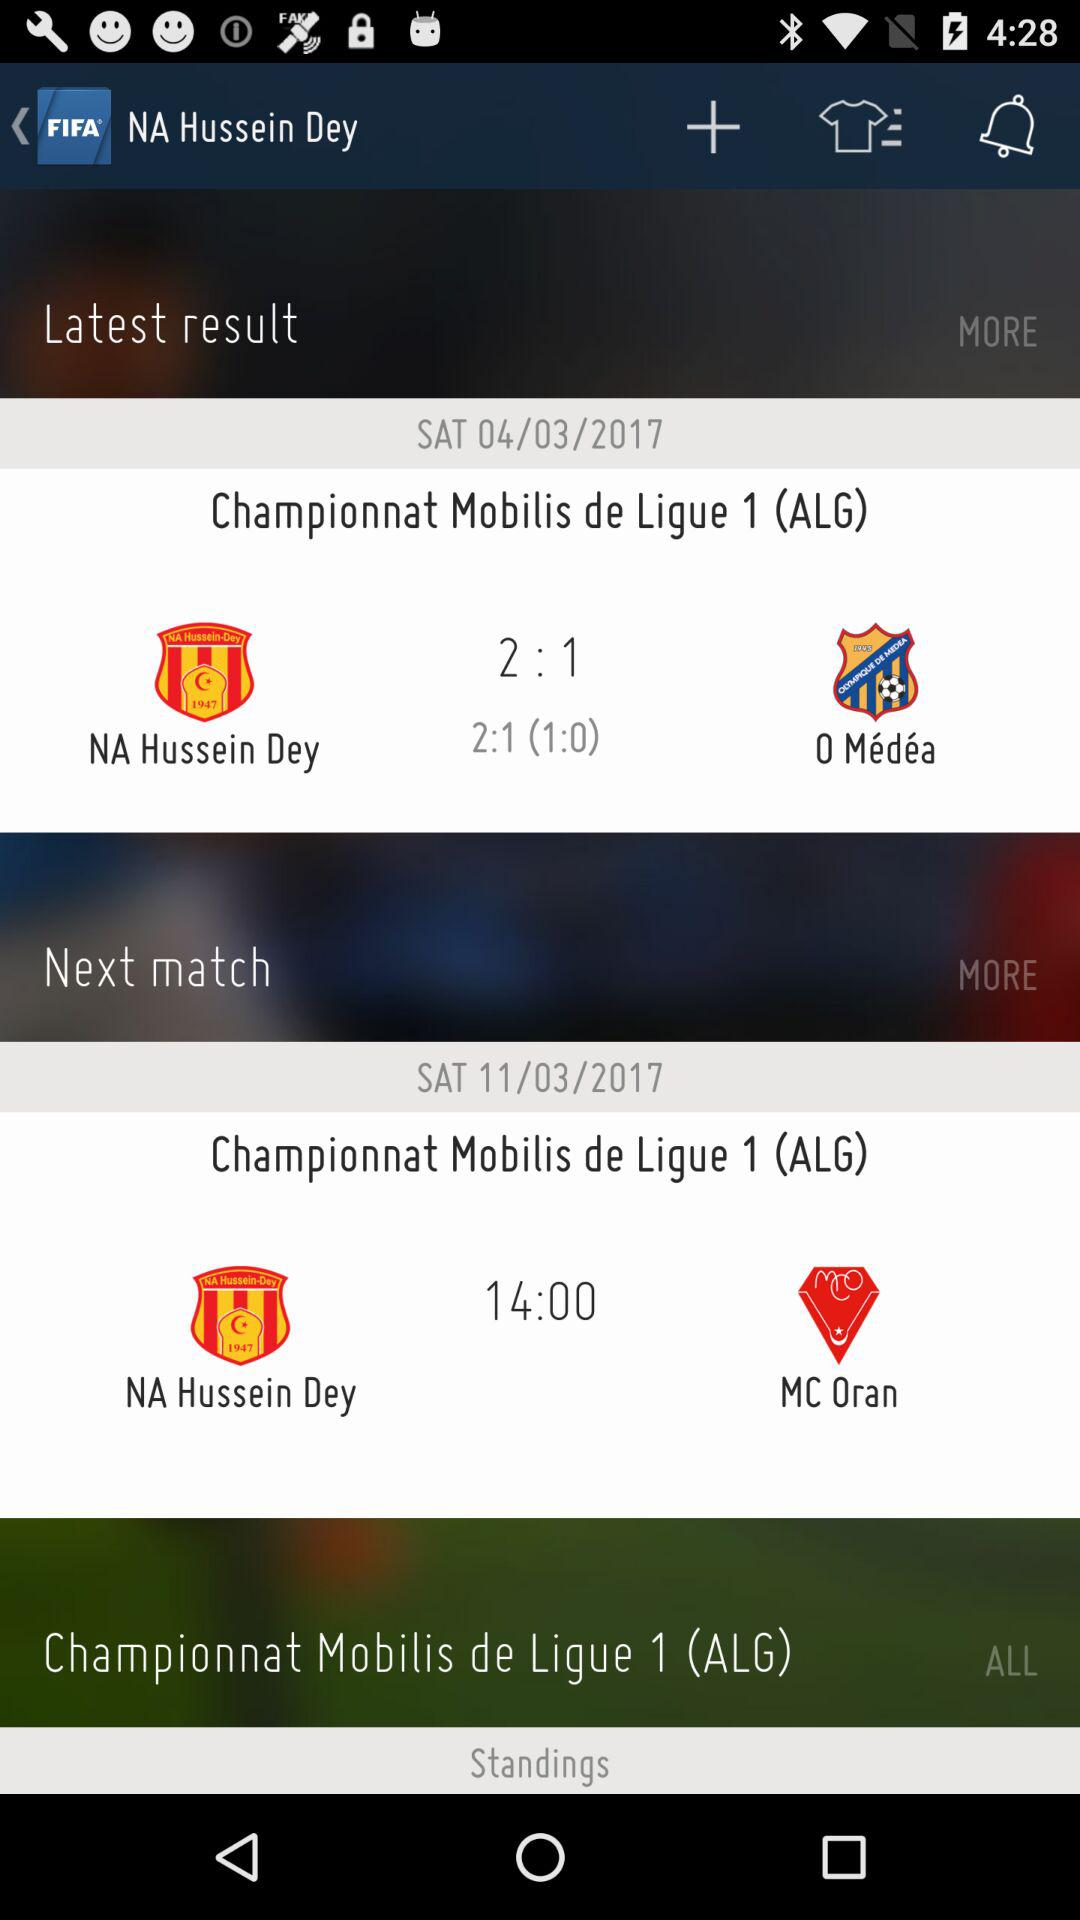How many notifications are there?
When the provided information is insufficient, respond with <no answer>. <no answer> 